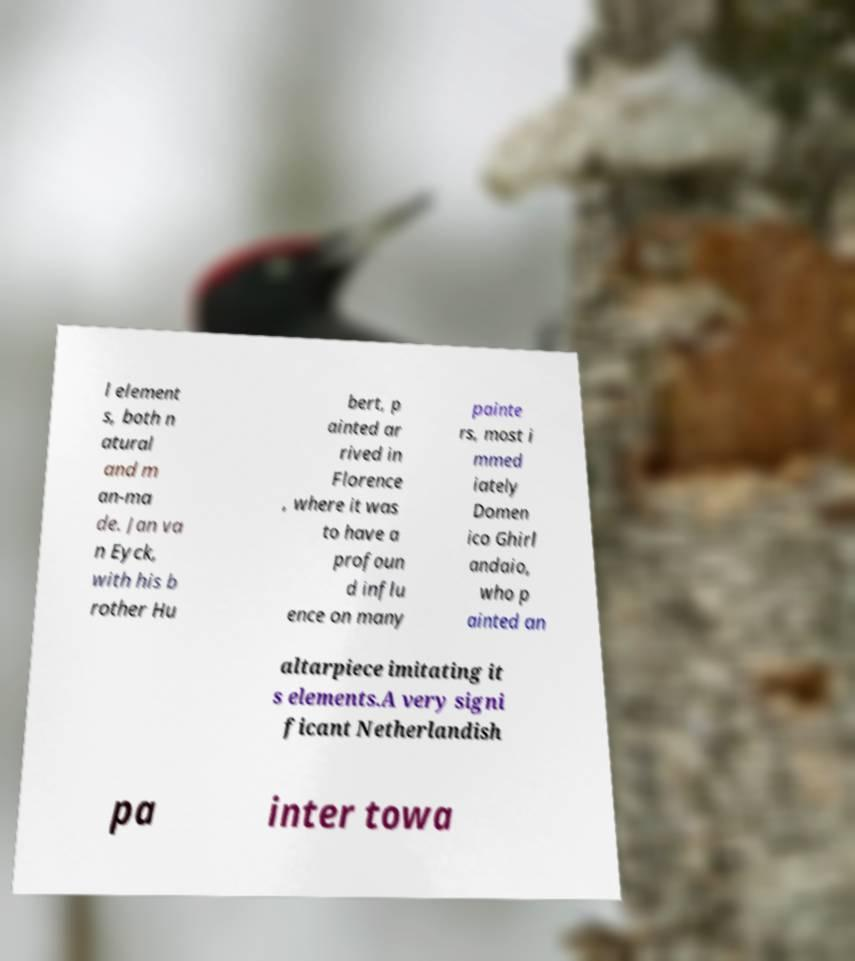Can you accurately transcribe the text from the provided image for me? l element s, both n atural and m an-ma de. Jan va n Eyck, with his b rother Hu bert, p ainted ar rived in Florence , where it was to have a profoun d influ ence on many painte rs, most i mmed iately Domen ico Ghirl andaio, who p ainted an altarpiece imitating it s elements.A very signi ficant Netherlandish pa inter towa 